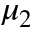Convert formula to latex. <formula><loc_0><loc_0><loc_500><loc_500>\mu _ { 2 }</formula> 